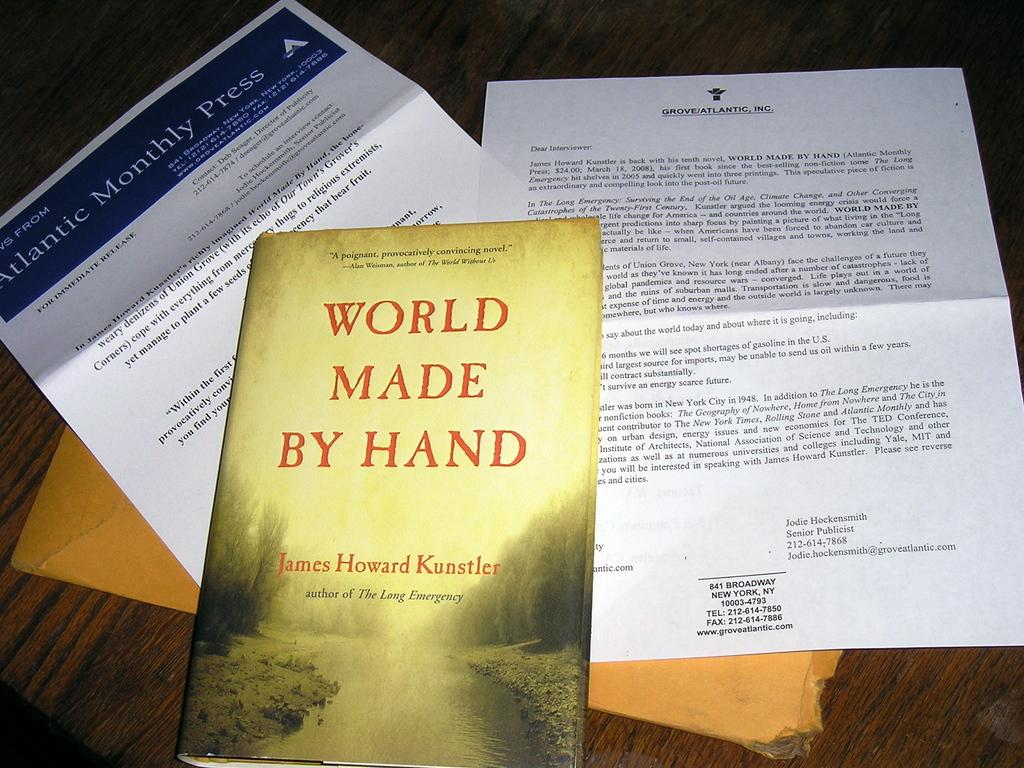Provide a one-sentence caption for the provided image. World Made by Hand lays on the table with some papers. 